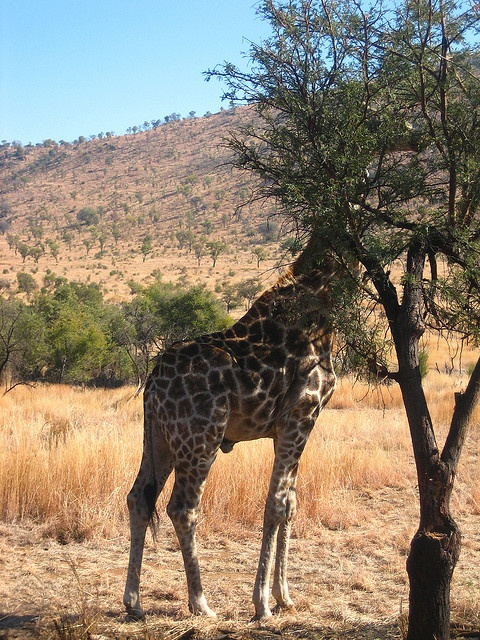Describe the objects in this image and their specific colors. I can see a giraffe in lightblue, black, gray, and maroon tones in this image. 